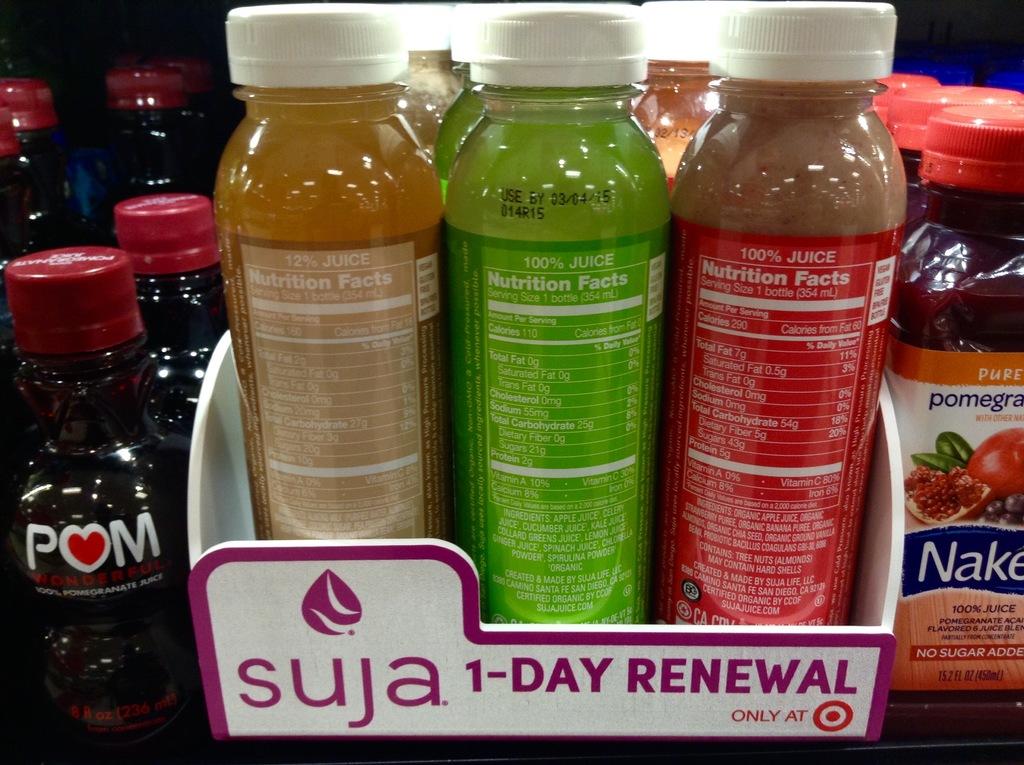How many days renewal?
Provide a succinct answer. 1. 